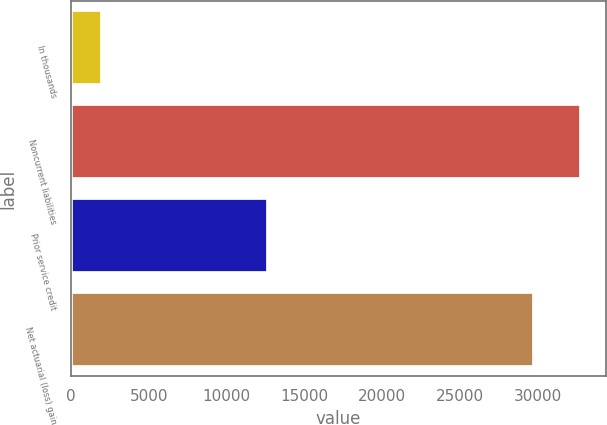Convert chart to OTSL. <chart><loc_0><loc_0><loc_500><loc_500><bar_chart><fcel>In thousands<fcel>Noncurrent liabilities<fcel>Prior service credit<fcel>Net actuarial (loss) gain<nl><fcel>2012<fcel>32747.6<fcel>12663<fcel>29719<nl></chart> 